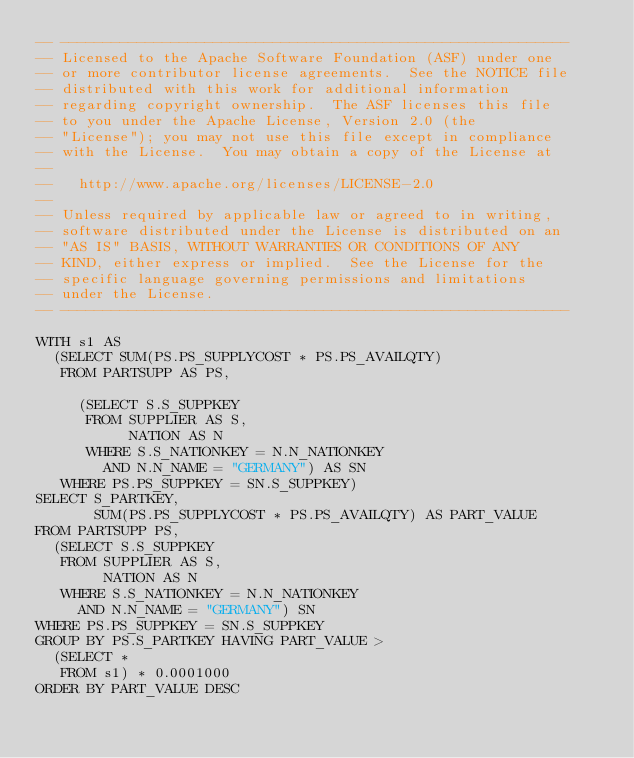Convert code to text. <code><loc_0><loc_0><loc_500><loc_500><_SQL_>-- ------------------------------------------------------------
-- Licensed to the Apache Software Foundation (ASF) under one
-- or more contributor license agreements.  See the NOTICE file
-- distributed with this work for additional information
-- regarding copyright ownership.  The ASF licenses this file
-- to you under the Apache License, Version 2.0 (the
-- "License"); you may not use this file except in compliance
-- with the License.  You may obtain a copy of the License at
--
--   http://www.apache.org/licenses/LICENSE-2.0
--
-- Unless required by applicable law or agreed to in writing,
-- software distributed under the License is distributed on an
-- "AS IS" BASIS, WITHOUT WARRANTIES OR CONDITIONS OF ANY
-- KIND, either express or implied.  See the License for the
-- specific language governing permissions and limitations
-- under the License.
-- ------------------------------------------------------------

WITH s1 AS
  (SELECT SUM(PS.PS_SUPPLYCOST * PS.PS_AVAILQTY)
   FROM PARTSUPP AS PS,

     (SELECT S.S_SUPPKEY
      FROM SUPPLIER AS S,
           NATION AS N
      WHERE S.S_NATIONKEY = N.N_NATIONKEY
        AND N.N_NAME = "GERMANY") AS SN
   WHERE PS.PS_SUPPKEY = SN.S_SUPPKEY)
SELECT S_PARTKEY,
       SUM(PS.PS_SUPPLYCOST * PS.PS_AVAILQTY) AS PART_VALUE
FROM PARTSUPP PS,
  (SELECT S.S_SUPPKEY
   FROM SUPPLIER AS S,
        NATION AS N
   WHERE S.S_NATIONKEY = N.N_NATIONKEY
     AND N.N_NAME = "GERMANY") SN
WHERE PS.PS_SUPPKEY = SN.S_SUPPKEY
GROUP BY PS.S_PARTKEY HAVING PART_VALUE >
  (SELECT *
   FROM s1) * 0.0001000
ORDER BY PART_VALUE DESC</code> 